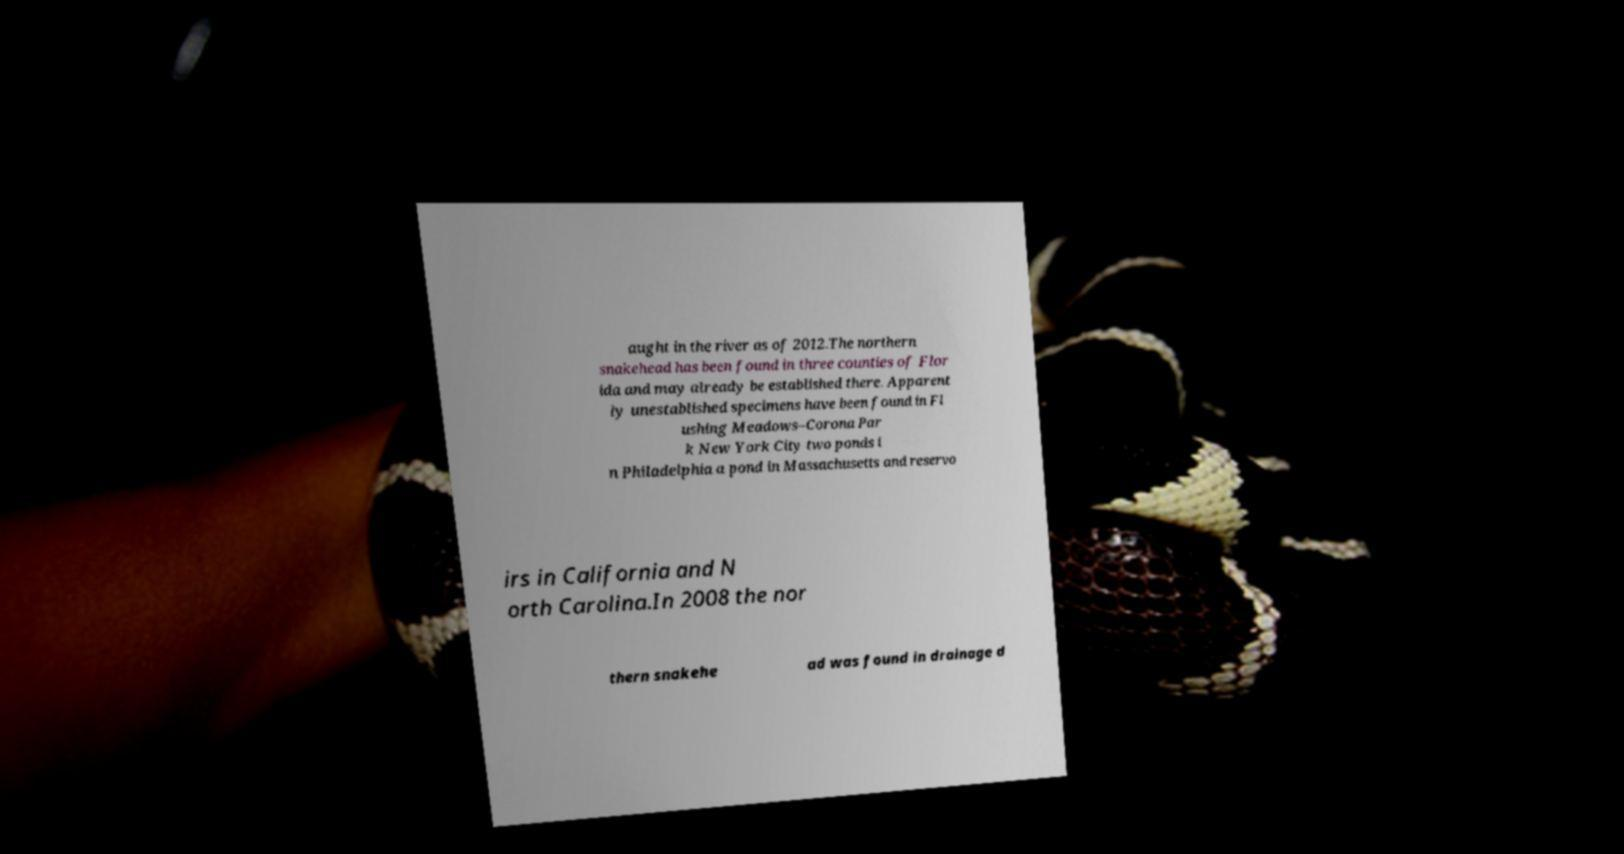Could you assist in decoding the text presented in this image and type it out clearly? aught in the river as of 2012.The northern snakehead has been found in three counties of Flor ida and may already be established there. Apparent ly unestablished specimens have been found in Fl ushing Meadows–Corona Par k New York City two ponds i n Philadelphia a pond in Massachusetts and reservo irs in California and N orth Carolina.In 2008 the nor thern snakehe ad was found in drainage d 